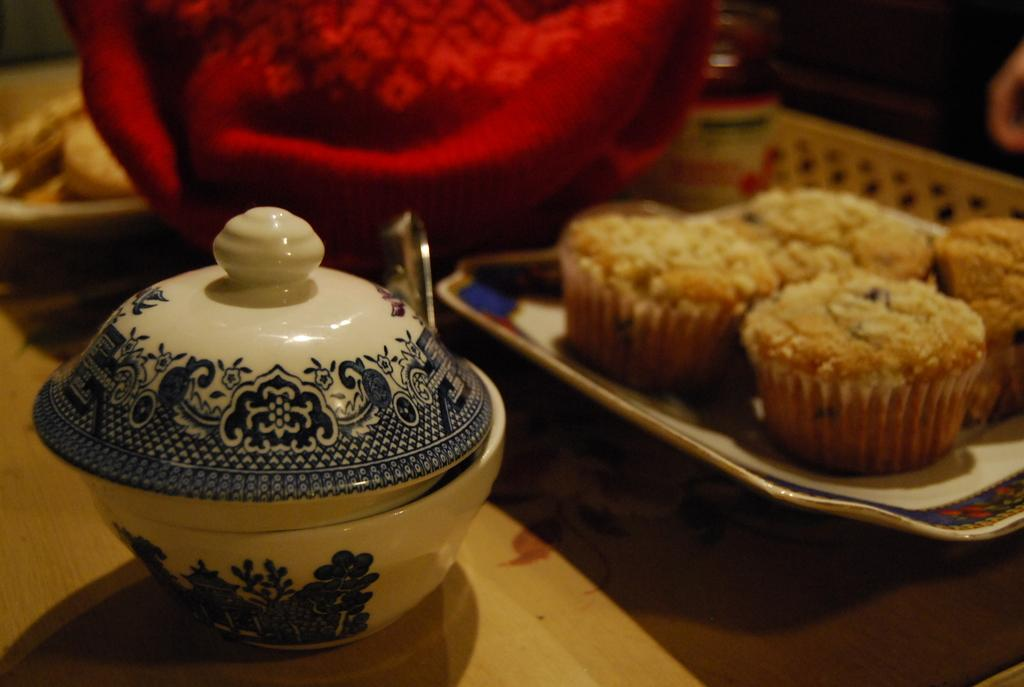What type of food can be seen in the image? There are muffins in the image. What is the container with a lid used for in the image? The bowl with a lid is present in the image. What is the surface on which objects are placed in the image? There are objects on a platform in the image. How would you describe the lighting in the image? The background of the image is dark. What type of teeth can be seen in the image? There are no teeth visible in the image. What event is about to start in the image? There is no indication of an event starting in the image. 